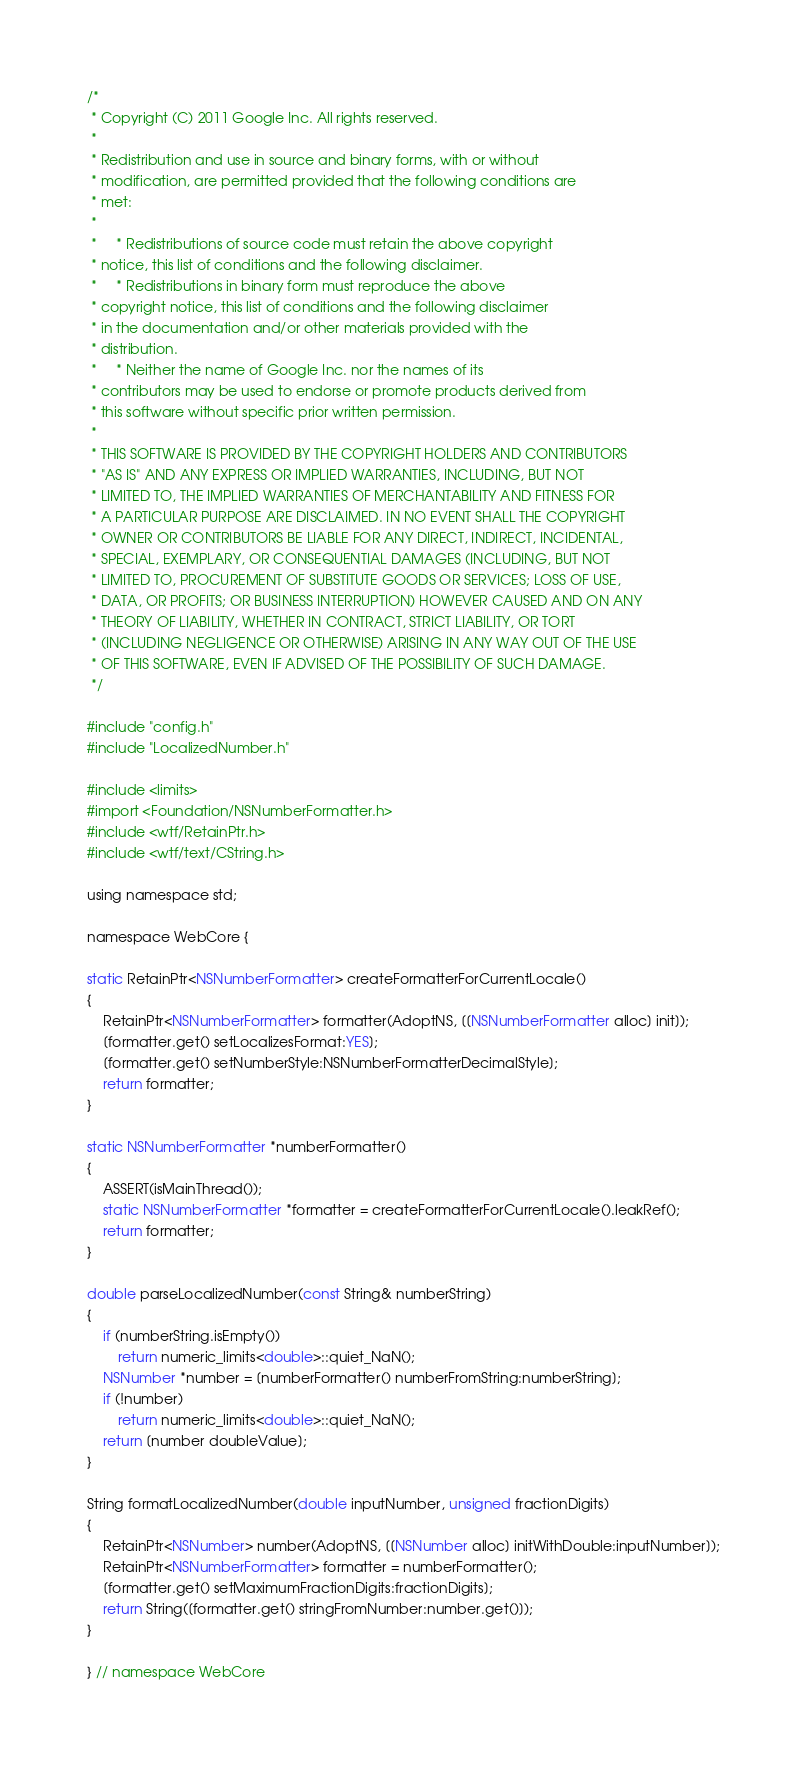Convert code to text. <code><loc_0><loc_0><loc_500><loc_500><_ObjectiveC_>/*
 * Copyright (C) 2011 Google Inc. All rights reserved.
 *
 * Redistribution and use in source and binary forms, with or without
 * modification, are permitted provided that the following conditions are
 * met:
 *
 *     * Redistributions of source code must retain the above copyright
 * notice, this list of conditions and the following disclaimer.
 *     * Redistributions in binary form must reproduce the above
 * copyright notice, this list of conditions and the following disclaimer
 * in the documentation and/or other materials provided with the
 * distribution.
 *     * Neither the name of Google Inc. nor the names of its
 * contributors may be used to endorse or promote products derived from
 * this software without specific prior written permission.
 *
 * THIS SOFTWARE IS PROVIDED BY THE COPYRIGHT HOLDERS AND CONTRIBUTORS
 * "AS IS" AND ANY EXPRESS OR IMPLIED WARRANTIES, INCLUDING, BUT NOT
 * LIMITED TO, THE IMPLIED WARRANTIES OF MERCHANTABILITY AND FITNESS FOR
 * A PARTICULAR PURPOSE ARE DISCLAIMED. IN NO EVENT SHALL THE COPYRIGHT
 * OWNER OR CONTRIBUTORS BE LIABLE FOR ANY DIRECT, INDIRECT, INCIDENTAL,
 * SPECIAL, EXEMPLARY, OR CONSEQUENTIAL DAMAGES (INCLUDING, BUT NOT
 * LIMITED TO, PROCUREMENT OF SUBSTITUTE GOODS OR SERVICES; LOSS OF USE,
 * DATA, OR PROFITS; OR BUSINESS INTERRUPTION) HOWEVER CAUSED AND ON ANY
 * THEORY OF LIABILITY, WHETHER IN CONTRACT, STRICT LIABILITY, OR TORT
 * (INCLUDING NEGLIGENCE OR OTHERWISE) ARISING IN ANY WAY OUT OF THE USE
 * OF THIS SOFTWARE, EVEN IF ADVISED OF THE POSSIBILITY OF SUCH DAMAGE.
 */

#include "config.h"
#include "LocalizedNumber.h"

#include <limits>
#import <Foundation/NSNumberFormatter.h>
#include <wtf/RetainPtr.h>
#include <wtf/text/CString.h>

using namespace std;

namespace WebCore {

static RetainPtr<NSNumberFormatter> createFormatterForCurrentLocale()
{
    RetainPtr<NSNumberFormatter> formatter(AdoptNS, [[NSNumberFormatter alloc] init]);
    [formatter.get() setLocalizesFormat:YES];
    [formatter.get() setNumberStyle:NSNumberFormatterDecimalStyle];
    return formatter;
}

static NSNumberFormatter *numberFormatter()
{
    ASSERT(isMainThread());
    static NSNumberFormatter *formatter = createFormatterForCurrentLocale().leakRef();
    return formatter;
}

double parseLocalizedNumber(const String& numberString)
{
    if (numberString.isEmpty())
        return numeric_limits<double>::quiet_NaN();
    NSNumber *number = [numberFormatter() numberFromString:numberString];
    if (!number)
        return numeric_limits<double>::quiet_NaN();
    return [number doubleValue];
}

String formatLocalizedNumber(double inputNumber, unsigned fractionDigits)
{
    RetainPtr<NSNumber> number(AdoptNS, [[NSNumber alloc] initWithDouble:inputNumber]);
    RetainPtr<NSNumberFormatter> formatter = numberFormatter();
    [formatter.get() setMaximumFractionDigits:fractionDigits];
    return String([formatter.get() stringFromNumber:number.get()]);
}

} // namespace WebCore

</code> 